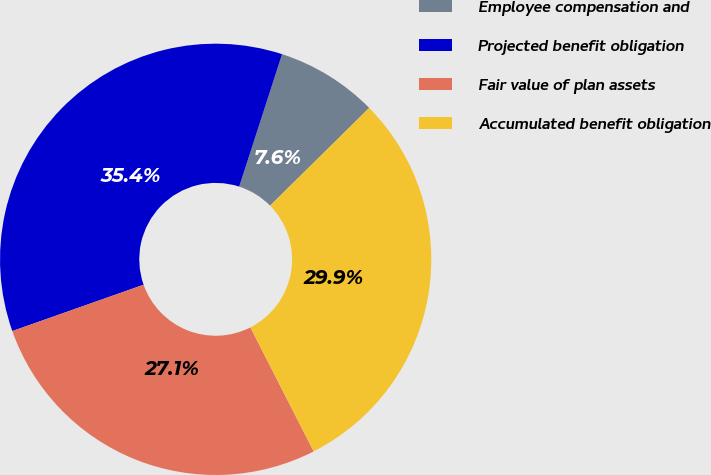Convert chart to OTSL. <chart><loc_0><loc_0><loc_500><loc_500><pie_chart><fcel>Employee compensation and<fcel>Projected benefit obligation<fcel>Fair value of plan assets<fcel>Accumulated benefit obligation<nl><fcel>7.63%<fcel>35.38%<fcel>27.11%<fcel>29.88%<nl></chart> 